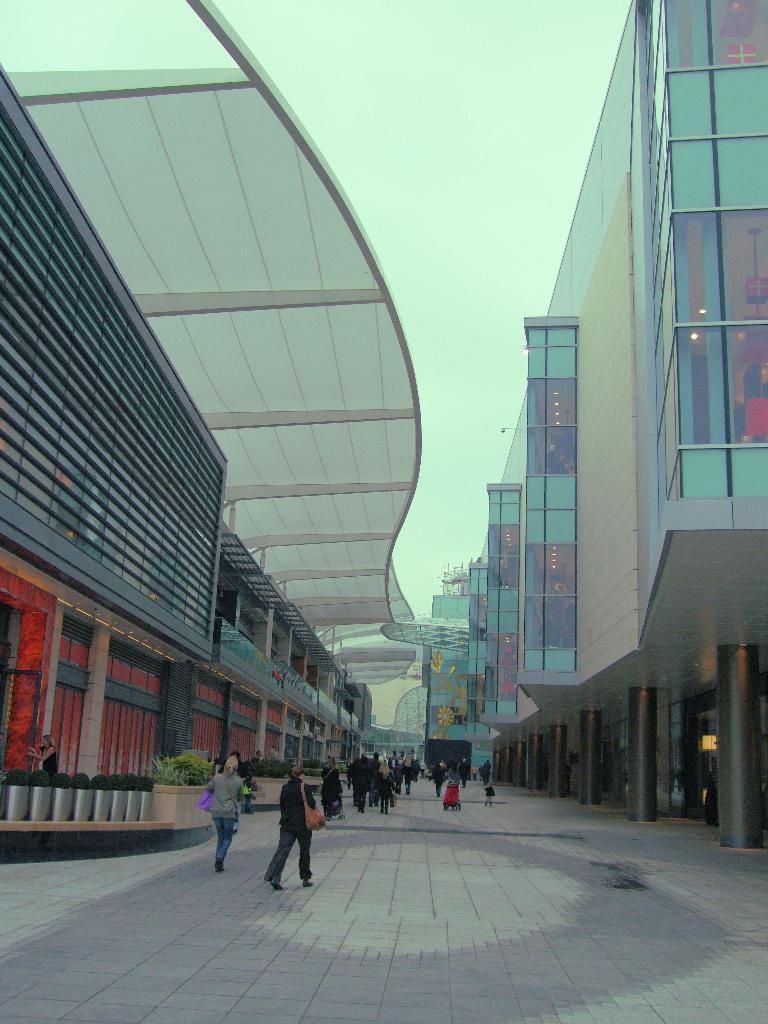Please provide a concise description of this image. This is a street view. On the right side there is a building with pillars. On the left side there is another building with pillars. On the sides there are plants. And many people are walking. In the background there is sky. 